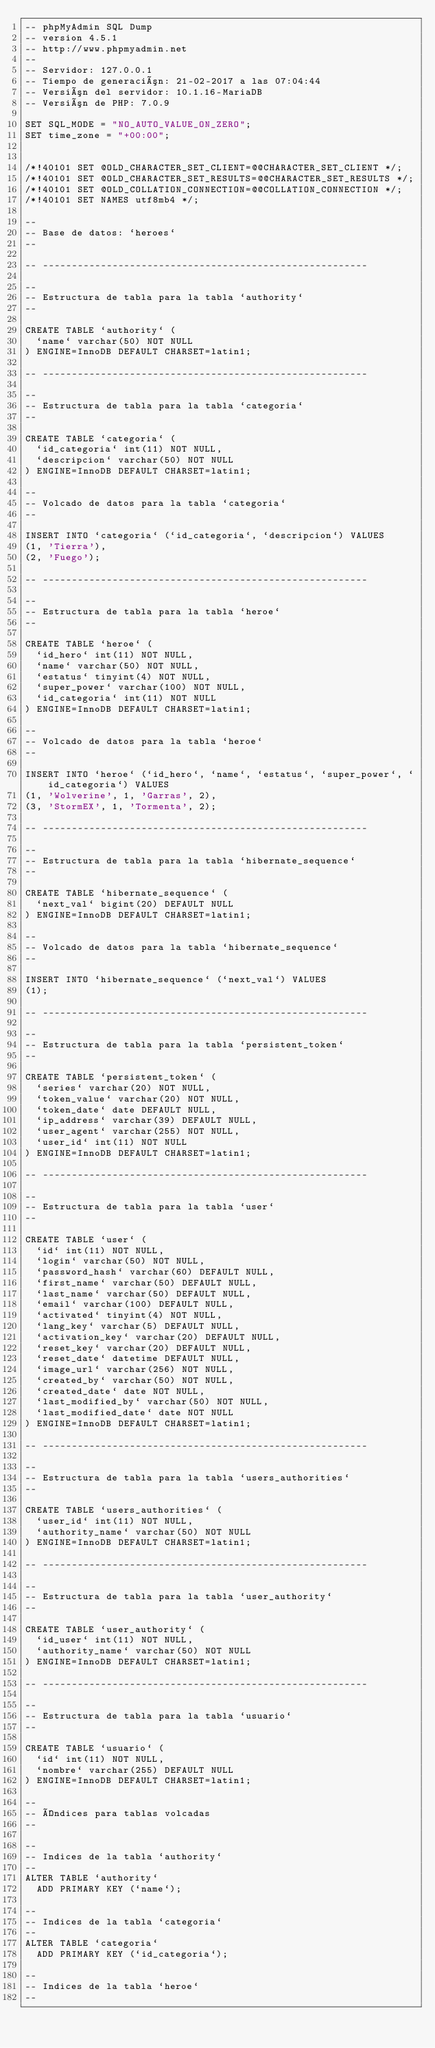<code> <loc_0><loc_0><loc_500><loc_500><_SQL_>-- phpMyAdmin SQL Dump
-- version 4.5.1
-- http://www.phpmyadmin.net
--
-- Servidor: 127.0.0.1
-- Tiempo de generación: 21-02-2017 a las 07:04:44
-- Versión del servidor: 10.1.16-MariaDB
-- Versión de PHP: 7.0.9

SET SQL_MODE = "NO_AUTO_VALUE_ON_ZERO";
SET time_zone = "+00:00";


/*!40101 SET @OLD_CHARACTER_SET_CLIENT=@@CHARACTER_SET_CLIENT */;
/*!40101 SET @OLD_CHARACTER_SET_RESULTS=@@CHARACTER_SET_RESULTS */;
/*!40101 SET @OLD_COLLATION_CONNECTION=@@COLLATION_CONNECTION */;
/*!40101 SET NAMES utf8mb4 */;

--
-- Base de datos: `heroes`
--

-- --------------------------------------------------------

--
-- Estructura de tabla para la tabla `authority`
--

CREATE TABLE `authority` (
  `name` varchar(50) NOT NULL
) ENGINE=InnoDB DEFAULT CHARSET=latin1;

-- --------------------------------------------------------

--
-- Estructura de tabla para la tabla `categoria`
--

CREATE TABLE `categoria` (
  `id_categoria` int(11) NOT NULL,
  `descripcion` varchar(50) NOT NULL
) ENGINE=InnoDB DEFAULT CHARSET=latin1;

--
-- Volcado de datos para la tabla `categoria`
--

INSERT INTO `categoria` (`id_categoria`, `descripcion`) VALUES
(1, 'Tierra'),
(2, 'Fuego');

-- --------------------------------------------------------

--
-- Estructura de tabla para la tabla `heroe`
--

CREATE TABLE `heroe` (
  `id_hero` int(11) NOT NULL,
  `name` varchar(50) NOT NULL,
  `estatus` tinyint(4) NOT NULL,
  `super_power` varchar(100) NOT NULL,
  `id_categoria` int(11) NOT NULL
) ENGINE=InnoDB DEFAULT CHARSET=latin1;

--
-- Volcado de datos para la tabla `heroe`
--

INSERT INTO `heroe` (`id_hero`, `name`, `estatus`, `super_power`, `id_categoria`) VALUES
(1, 'Wolverine', 1, 'Garras', 2),
(3, 'StormEX', 1, 'Tormenta', 2);

-- --------------------------------------------------------

--
-- Estructura de tabla para la tabla `hibernate_sequence`
--

CREATE TABLE `hibernate_sequence` (
  `next_val` bigint(20) DEFAULT NULL
) ENGINE=InnoDB DEFAULT CHARSET=latin1;

--
-- Volcado de datos para la tabla `hibernate_sequence`
--

INSERT INTO `hibernate_sequence` (`next_val`) VALUES
(1);

-- --------------------------------------------------------

--
-- Estructura de tabla para la tabla `persistent_token`
--

CREATE TABLE `persistent_token` (
  `series` varchar(20) NOT NULL,
  `token_value` varchar(20) NOT NULL,
  `token_date` date DEFAULT NULL,
  `ip_address` varchar(39) DEFAULT NULL,
  `user_agent` varchar(255) NOT NULL,
  `user_id` int(11) NOT NULL
) ENGINE=InnoDB DEFAULT CHARSET=latin1;

-- --------------------------------------------------------

--
-- Estructura de tabla para la tabla `user`
--

CREATE TABLE `user` (
  `id` int(11) NOT NULL,
  `login` varchar(50) NOT NULL,
  `password_hash` varchar(60) DEFAULT NULL,
  `first_name` varchar(50) DEFAULT NULL,
  `last_name` varchar(50) DEFAULT NULL,
  `email` varchar(100) DEFAULT NULL,
  `activated` tinyint(4) NOT NULL,
  `lang_key` varchar(5) DEFAULT NULL,
  `activation_key` varchar(20) DEFAULT NULL,
  `reset_key` varchar(20) DEFAULT NULL,
  `reset_date` datetime DEFAULT NULL,
  `image_url` varchar(256) NOT NULL,
  `created_by` varchar(50) NOT NULL,
  `created_date` date NOT NULL,
  `last_modified_by` varchar(50) NOT NULL,
  `last_modified_date` date NOT NULL
) ENGINE=InnoDB DEFAULT CHARSET=latin1;

-- --------------------------------------------------------

--
-- Estructura de tabla para la tabla `users_authorities`
--

CREATE TABLE `users_authorities` (
  `user_id` int(11) NOT NULL,
  `authority_name` varchar(50) NOT NULL
) ENGINE=InnoDB DEFAULT CHARSET=latin1;

-- --------------------------------------------------------

--
-- Estructura de tabla para la tabla `user_authority`
--

CREATE TABLE `user_authority` (
  `id_user` int(11) NOT NULL,
  `authority_name` varchar(50) NOT NULL
) ENGINE=InnoDB DEFAULT CHARSET=latin1;

-- --------------------------------------------------------

--
-- Estructura de tabla para la tabla `usuario`
--

CREATE TABLE `usuario` (
  `id` int(11) NOT NULL,
  `nombre` varchar(255) DEFAULT NULL
) ENGINE=InnoDB DEFAULT CHARSET=latin1;

--
-- Índices para tablas volcadas
--

--
-- Indices de la tabla `authority`
--
ALTER TABLE `authority`
  ADD PRIMARY KEY (`name`);

--
-- Indices de la tabla `categoria`
--
ALTER TABLE `categoria`
  ADD PRIMARY KEY (`id_categoria`);

--
-- Indices de la tabla `heroe`
--</code> 